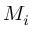<formula> <loc_0><loc_0><loc_500><loc_500>M _ { i }</formula> 